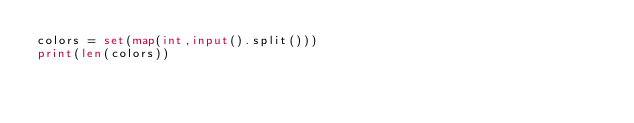Convert code to text. <code><loc_0><loc_0><loc_500><loc_500><_Python_>colors = set(map(int,input().split()))
print(len(colors))</code> 